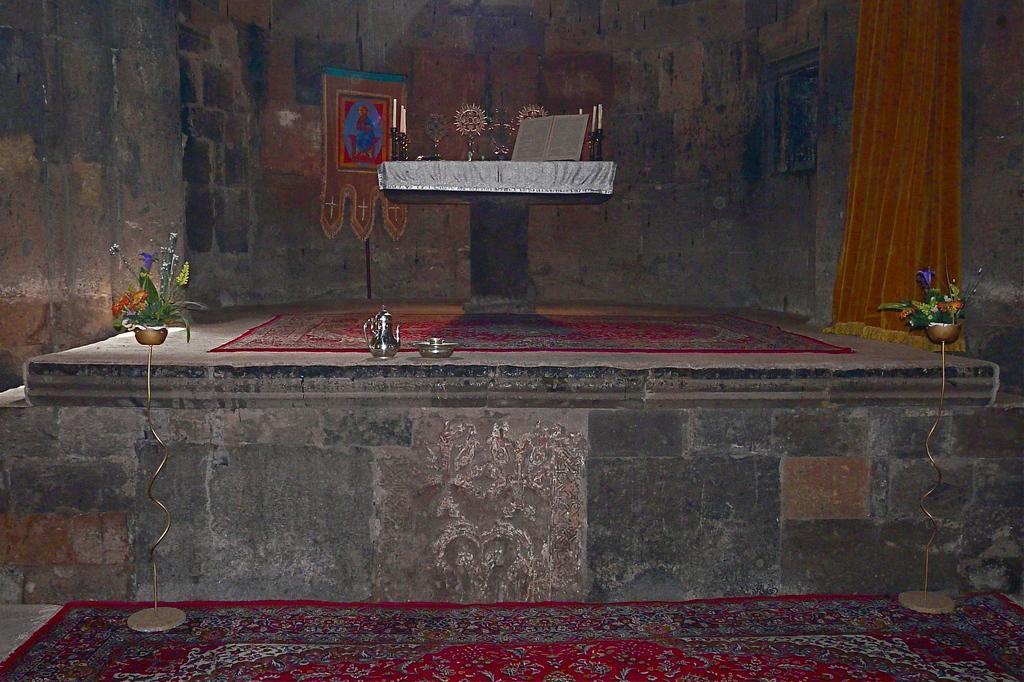Please provide a concise description of this image. In the foreground I can see a stage, bowl, houseplant, table on which there are trophies and a wall on which a wall painting is there, curtain. This image is taken in a hall. 